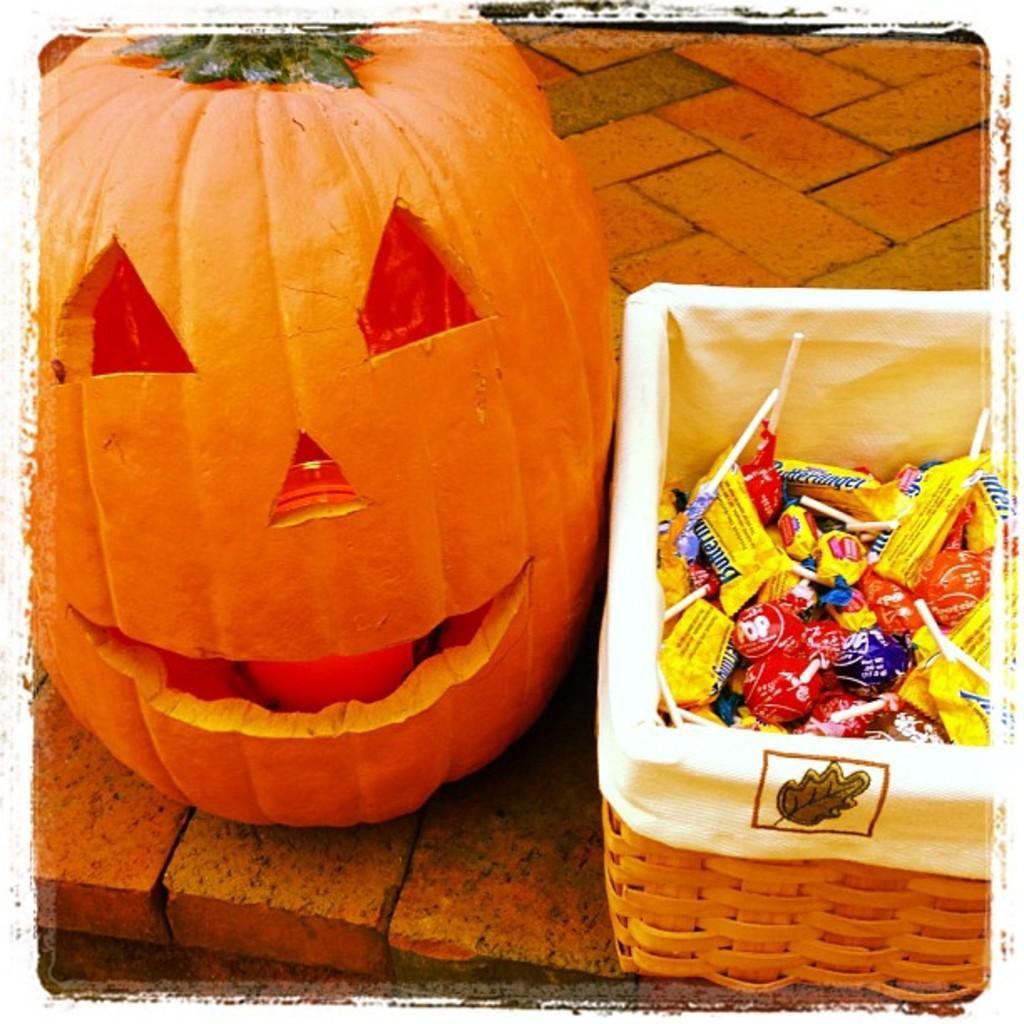Can you describe this image briefly? In this image I can see a vegetable which is in orange color, right I can see few chocolates in the basket and the chocolates are in multi color. 